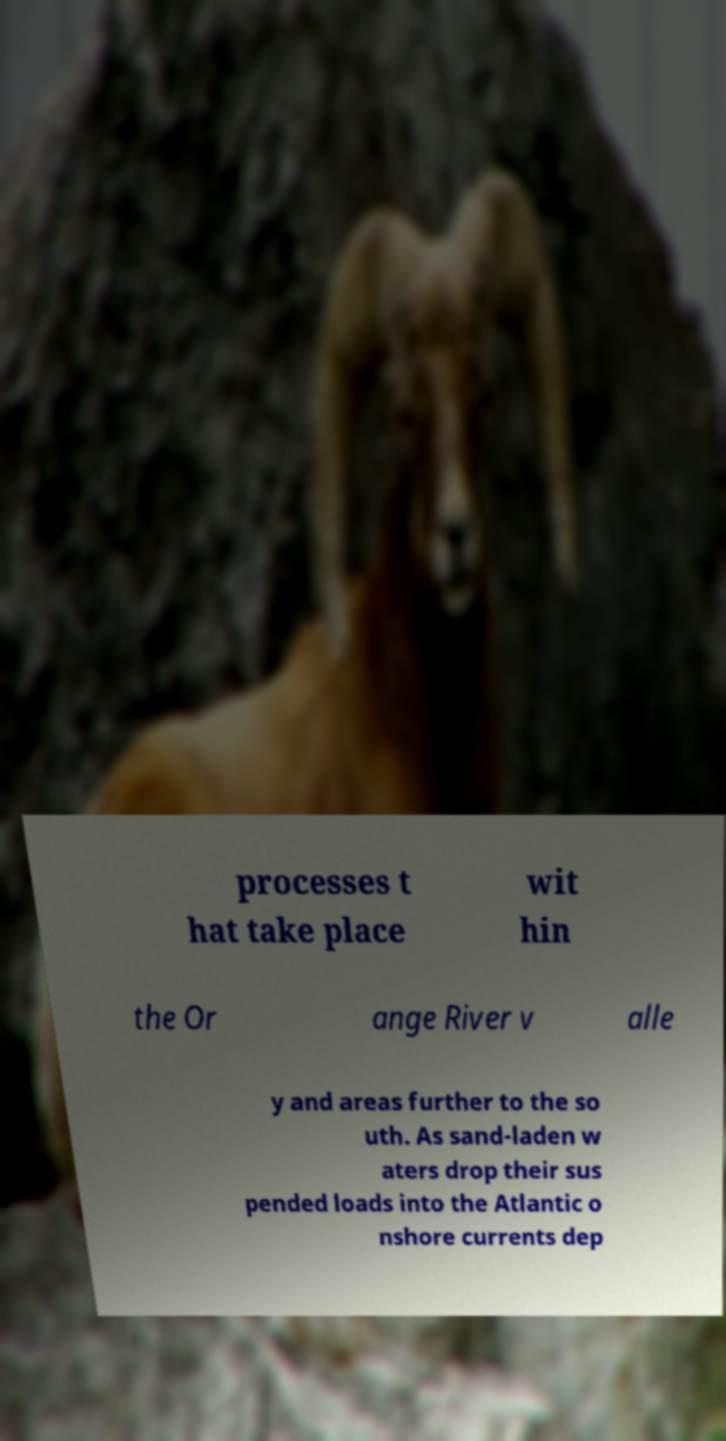For documentation purposes, I need the text within this image transcribed. Could you provide that? processes t hat take place wit hin the Or ange River v alle y and areas further to the so uth. As sand-laden w aters drop their sus pended loads into the Atlantic o nshore currents dep 